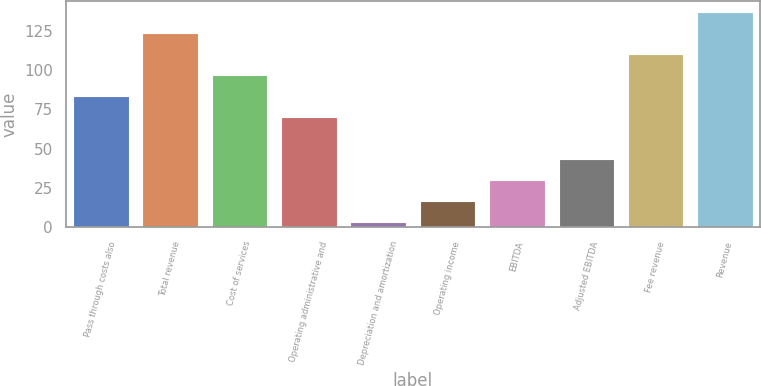Convert chart to OTSL. <chart><loc_0><loc_0><loc_500><loc_500><bar_chart><fcel>Pass through costs also<fcel>Total revenue<fcel>Cost of services<fcel>Operating administrative and<fcel>Depreciation and amortization<fcel>Operating income<fcel>EBITDA<fcel>Adjusted EBITDA<fcel>Fee revenue<fcel>Revenue<nl><fcel>83.6<fcel>123.8<fcel>97<fcel>70.2<fcel>3.2<fcel>16.6<fcel>30<fcel>43.4<fcel>110.4<fcel>137.2<nl></chart> 